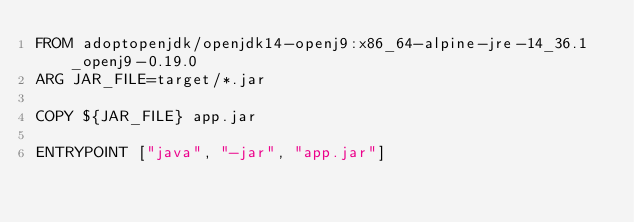<code> <loc_0><loc_0><loc_500><loc_500><_Dockerfile_>FROM adoptopenjdk/openjdk14-openj9:x86_64-alpine-jre-14_36.1_openj9-0.19.0
ARG JAR_FILE=target/*.jar

COPY ${JAR_FILE} app.jar

ENTRYPOINT ["java", "-jar", "app.jar"]
</code> 